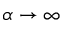Convert formula to latex. <formula><loc_0><loc_0><loc_500><loc_500>\alpha \to \infty</formula> 